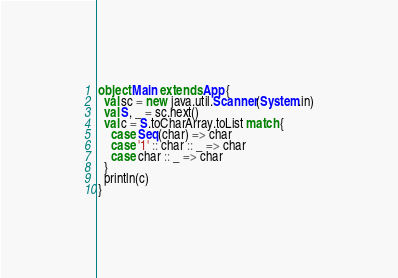<code> <loc_0><loc_0><loc_500><loc_500><_Scala_>object Main extends App {
  val sc = new java.util.Scanner(System.in)
  val S, _ = sc.next()
  val c = S.toCharArray.toList match {
    case Seq(char) => char
    case '1' :: char :: _ => char
    case char :: _ => char
  }
  println(c)
}
</code> 